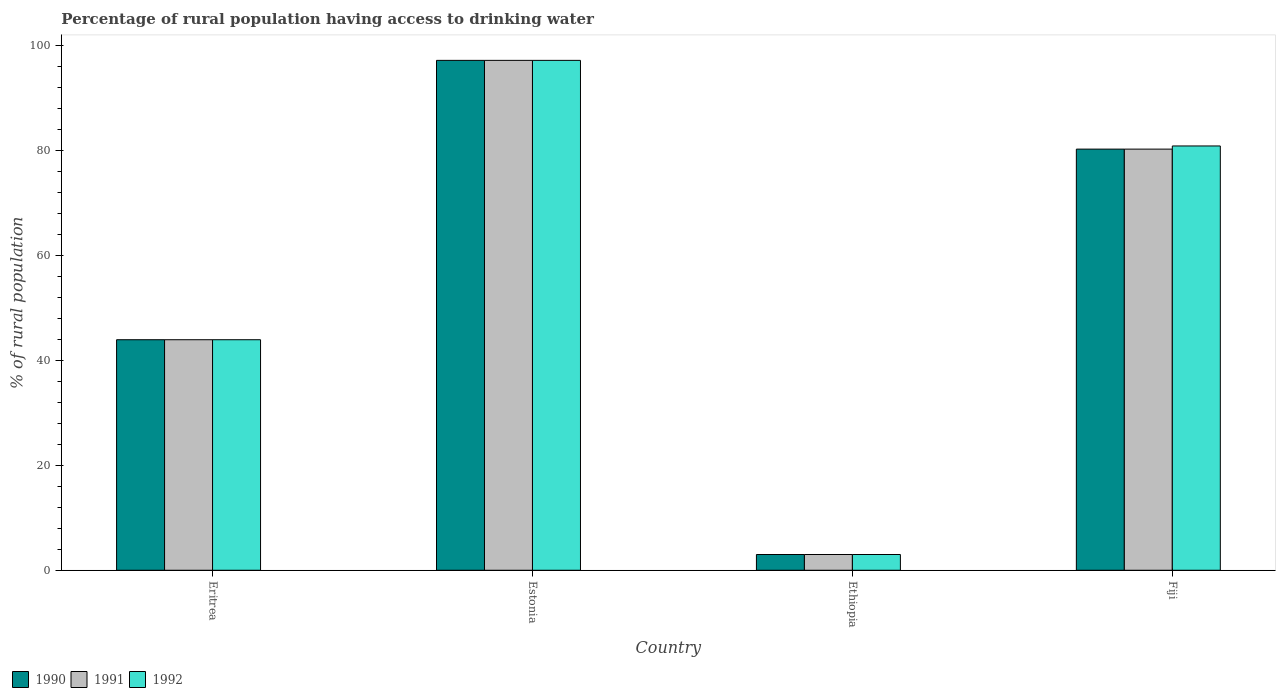How many groups of bars are there?
Make the answer very short. 4. Are the number of bars per tick equal to the number of legend labels?
Keep it short and to the point. Yes. Are the number of bars on each tick of the X-axis equal?
Ensure brevity in your answer.  Yes. How many bars are there on the 3rd tick from the right?
Provide a short and direct response. 3. What is the label of the 3rd group of bars from the left?
Offer a terse response. Ethiopia. What is the percentage of rural population having access to drinking water in 1990 in Eritrea?
Your response must be concise. 43.9. Across all countries, what is the maximum percentage of rural population having access to drinking water in 1990?
Give a very brief answer. 97.1. Across all countries, what is the minimum percentage of rural population having access to drinking water in 1992?
Give a very brief answer. 3. In which country was the percentage of rural population having access to drinking water in 1991 maximum?
Your response must be concise. Estonia. In which country was the percentage of rural population having access to drinking water in 1992 minimum?
Your answer should be compact. Ethiopia. What is the total percentage of rural population having access to drinking water in 1992 in the graph?
Your answer should be compact. 224.8. What is the difference between the percentage of rural population having access to drinking water in 1990 in Ethiopia and that in Fiji?
Offer a terse response. -77.2. What is the difference between the percentage of rural population having access to drinking water in 1990 in Fiji and the percentage of rural population having access to drinking water in 1991 in Ethiopia?
Provide a short and direct response. 77.2. What is the average percentage of rural population having access to drinking water in 1990 per country?
Give a very brief answer. 56.05. In how many countries, is the percentage of rural population having access to drinking water in 1990 greater than 76 %?
Keep it short and to the point. 2. What is the ratio of the percentage of rural population having access to drinking water in 1990 in Ethiopia to that in Fiji?
Your answer should be very brief. 0.04. Is the percentage of rural population having access to drinking water in 1992 in Estonia less than that in Fiji?
Your answer should be very brief. No. What is the difference between the highest and the second highest percentage of rural population having access to drinking water in 1990?
Give a very brief answer. -16.9. What is the difference between the highest and the lowest percentage of rural population having access to drinking water in 1992?
Make the answer very short. 94.1. Is the sum of the percentage of rural population having access to drinking water in 1990 in Estonia and Ethiopia greater than the maximum percentage of rural population having access to drinking water in 1991 across all countries?
Provide a short and direct response. Yes. What does the 1st bar from the right in Ethiopia represents?
Make the answer very short. 1992. Is it the case that in every country, the sum of the percentage of rural population having access to drinking water in 1990 and percentage of rural population having access to drinking water in 1991 is greater than the percentage of rural population having access to drinking water in 1992?
Ensure brevity in your answer.  Yes. How many bars are there?
Your answer should be compact. 12. How many countries are there in the graph?
Offer a very short reply. 4. What is the difference between two consecutive major ticks on the Y-axis?
Make the answer very short. 20. Does the graph contain any zero values?
Ensure brevity in your answer.  No. How many legend labels are there?
Your answer should be compact. 3. How are the legend labels stacked?
Provide a succinct answer. Horizontal. What is the title of the graph?
Your answer should be very brief. Percentage of rural population having access to drinking water. What is the label or title of the X-axis?
Your response must be concise. Country. What is the label or title of the Y-axis?
Your response must be concise. % of rural population. What is the % of rural population of 1990 in Eritrea?
Offer a terse response. 43.9. What is the % of rural population in 1991 in Eritrea?
Provide a succinct answer. 43.9. What is the % of rural population of 1992 in Eritrea?
Provide a short and direct response. 43.9. What is the % of rural population of 1990 in Estonia?
Make the answer very short. 97.1. What is the % of rural population of 1991 in Estonia?
Provide a short and direct response. 97.1. What is the % of rural population of 1992 in Estonia?
Give a very brief answer. 97.1. What is the % of rural population of 1990 in Ethiopia?
Provide a succinct answer. 3. What is the % of rural population of 1991 in Ethiopia?
Your answer should be very brief. 3. What is the % of rural population in 1990 in Fiji?
Your response must be concise. 80.2. What is the % of rural population in 1991 in Fiji?
Give a very brief answer. 80.2. What is the % of rural population in 1992 in Fiji?
Provide a succinct answer. 80.8. Across all countries, what is the maximum % of rural population in 1990?
Keep it short and to the point. 97.1. Across all countries, what is the maximum % of rural population of 1991?
Keep it short and to the point. 97.1. Across all countries, what is the maximum % of rural population in 1992?
Your response must be concise. 97.1. Across all countries, what is the minimum % of rural population of 1991?
Make the answer very short. 3. What is the total % of rural population of 1990 in the graph?
Give a very brief answer. 224.2. What is the total % of rural population in 1991 in the graph?
Keep it short and to the point. 224.2. What is the total % of rural population of 1992 in the graph?
Keep it short and to the point. 224.8. What is the difference between the % of rural population in 1990 in Eritrea and that in Estonia?
Provide a short and direct response. -53.2. What is the difference between the % of rural population in 1991 in Eritrea and that in Estonia?
Provide a short and direct response. -53.2. What is the difference between the % of rural population of 1992 in Eritrea and that in Estonia?
Your response must be concise. -53.2. What is the difference between the % of rural population of 1990 in Eritrea and that in Ethiopia?
Provide a succinct answer. 40.9. What is the difference between the % of rural population in 1991 in Eritrea and that in Ethiopia?
Your answer should be compact. 40.9. What is the difference between the % of rural population in 1992 in Eritrea and that in Ethiopia?
Give a very brief answer. 40.9. What is the difference between the % of rural population in 1990 in Eritrea and that in Fiji?
Your answer should be very brief. -36.3. What is the difference between the % of rural population in 1991 in Eritrea and that in Fiji?
Your answer should be compact. -36.3. What is the difference between the % of rural population of 1992 in Eritrea and that in Fiji?
Your answer should be very brief. -36.9. What is the difference between the % of rural population in 1990 in Estonia and that in Ethiopia?
Your answer should be compact. 94.1. What is the difference between the % of rural population in 1991 in Estonia and that in Ethiopia?
Keep it short and to the point. 94.1. What is the difference between the % of rural population of 1992 in Estonia and that in Ethiopia?
Give a very brief answer. 94.1. What is the difference between the % of rural population in 1991 in Estonia and that in Fiji?
Ensure brevity in your answer.  16.9. What is the difference between the % of rural population in 1990 in Ethiopia and that in Fiji?
Provide a short and direct response. -77.2. What is the difference between the % of rural population of 1991 in Ethiopia and that in Fiji?
Offer a terse response. -77.2. What is the difference between the % of rural population of 1992 in Ethiopia and that in Fiji?
Your answer should be very brief. -77.8. What is the difference between the % of rural population in 1990 in Eritrea and the % of rural population in 1991 in Estonia?
Give a very brief answer. -53.2. What is the difference between the % of rural population of 1990 in Eritrea and the % of rural population of 1992 in Estonia?
Ensure brevity in your answer.  -53.2. What is the difference between the % of rural population of 1991 in Eritrea and the % of rural population of 1992 in Estonia?
Offer a terse response. -53.2. What is the difference between the % of rural population of 1990 in Eritrea and the % of rural population of 1991 in Ethiopia?
Offer a very short reply. 40.9. What is the difference between the % of rural population in 1990 in Eritrea and the % of rural population in 1992 in Ethiopia?
Your answer should be compact. 40.9. What is the difference between the % of rural population in 1991 in Eritrea and the % of rural population in 1992 in Ethiopia?
Provide a succinct answer. 40.9. What is the difference between the % of rural population of 1990 in Eritrea and the % of rural population of 1991 in Fiji?
Provide a succinct answer. -36.3. What is the difference between the % of rural population in 1990 in Eritrea and the % of rural population in 1992 in Fiji?
Offer a very short reply. -36.9. What is the difference between the % of rural population of 1991 in Eritrea and the % of rural population of 1992 in Fiji?
Provide a succinct answer. -36.9. What is the difference between the % of rural population of 1990 in Estonia and the % of rural population of 1991 in Ethiopia?
Provide a short and direct response. 94.1. What is the difference between the % of rural population in 1990 in Estonia and the % of rural population in 1992 in Ethiopia?
Give a very brief answer. 94.1. What is the difference between the % of rural population in 1991 in Estonia and the % of rural population in 1992 in Ethiopia?
Your response must be concise. 94.1. What is the difference between the % of rural population of 1990 in Estonia and the % of rural population of 1992 in Fiji?
Offer a very short reply. 16.3. What is the difference between the % of rural population in 1991 in Estonia and the % of rural population in 1992 in Fiji?
Make the answer very short. 16.3. What is the difference between the % of rural population of 1990 in Ethiopia and the % of rural population of 1991 in Fiji?
Make the answer very short. -77.2. What is the difference between the % of rural population in 1990 in Ethiopia and the % of rural population in 1992 in Fiji?
Keep it short and to the point. -77.8. What is the difference between the % of rural population in 1991 in Ethiopia and the % of rural population in 1992 in Fiji?
Provide a short and direct response. -77.8. What is the average % of rural population in 1990 per country?
Provide a short and direct response. 56.05. What is the average % of rural population of 1991 per country?
Ensure brevity in your answer.  56.05. What is the average % of rural population of 1992 per country?
Ensure brevity in your answer.  56.2. What is the difference between the % of rural population in 1990 and % of rural population in 1991 in Eritrea?
Give a very brief answer. 0. What is the difference between the % of rural population of 1990 and % of rural population of 1992 in Eritrea?
Your answer should be very brief. 0. What is the difference between the % of rural population of 1990 and % of rural population of 1992 in Estonia?
Offer a terse response. 0. What is the difference between the % of rural population of 1991 and % of rural population of 1992 in Estonia?
Offer a terse response. 0. What is the difference between the % of rural population in 1990 and % of rural population in 1992 in Ethiopia?
Your response must be concise. 0. What is the ratio of the % of rural population of 1990 in Eritrea to that in Estonia?
Keep it short and to the point. 0.45. What is the ratio of the % of rural population of 1991 in Eritrea to that in Estonia?
Make the answer very short. 0.45. What is the ratio of the % of rural population of 1992 in Eritrea to that in Estonia?
Make the answer very short. 0.45. What is the ratio of the % of rural population of 1990 in Eritrea to that in Ethiopia?
Ensure brevity in your answer.  14.63. What is the ratio of the % of rural population of 1991 in Eritrea to that in Ethiopia?
Make the answer very short. 14.63. What is the ratio of the % of rural population in 1992 in Eritrea to that in Ethiopia?
Provide a succinct answer. 14.63. What is the ratio of the % of rural population of 1990 in Eritrea to that in Fiji?
Make the answer very short. 0.55. What is the ratio of the % of rural population in 1991 in Eritrea to that in Fiji?
Your response must be concise. 0.55. What is the ratio of the % of rural population of 1992 in Eritrea to that in Fiji?
Your answer should be compact. 0.54. What is the ratio of the % of rural population of 1990 in Estonia to that in Ethiopia?
Provide a short and direct response. 32.37. What is the ratio of the % of rural population in 1991 in Estonia to that in Ethiopia?
Your response must be concise. 32.37. What is the ratio of the % of rural population of 1992 in Estonia to that in Ethiopia?
Give a very brief answer. 32.37. What is the ratio of the % of rural population in 1990 in Estonia to that in Fiji?
Give a very brief answer. 1.21. What is the ratio of the % of rural population of 1991 in Estonia to that in Fiji?
Offer a very short reply. 1.21. What is the ratio of the % of rural population of 1992 in Estonia to that in Fiji?
Your answer should be very brief. 1.2. What is the ratio of the % of rural population of 1990 in Ethiopia to that in Fiji?
Give a very brief answer. 0.04. What is the ratio of the % of rural population in 1991 in Ethiopia to that in Fiji?
Give a very brief answer. 0.04. What is the ratio of the % of rural population of 1992 in Ethiopia to that in Fiji?
Your answer should be very brief. 0.04. What is the difference between the highest and the second highest % of rural population of 1990?
Your answer should be very brief. 16.9. What is the difference between the highest and the second highest % of rural population of 1992?
Your response must be concise. 16.3. What is the difference between the highest and the lowest % of rural population in 1990?
Ensure brevity in your answer.  94.1. What is the difference between the highest and the lowest % of rural population of 1991?
Offer a very short reply. 94.1. What is the difference between the highest and the lowest % of rural population in 1992?
Provide a short and direct response. 94.1. 